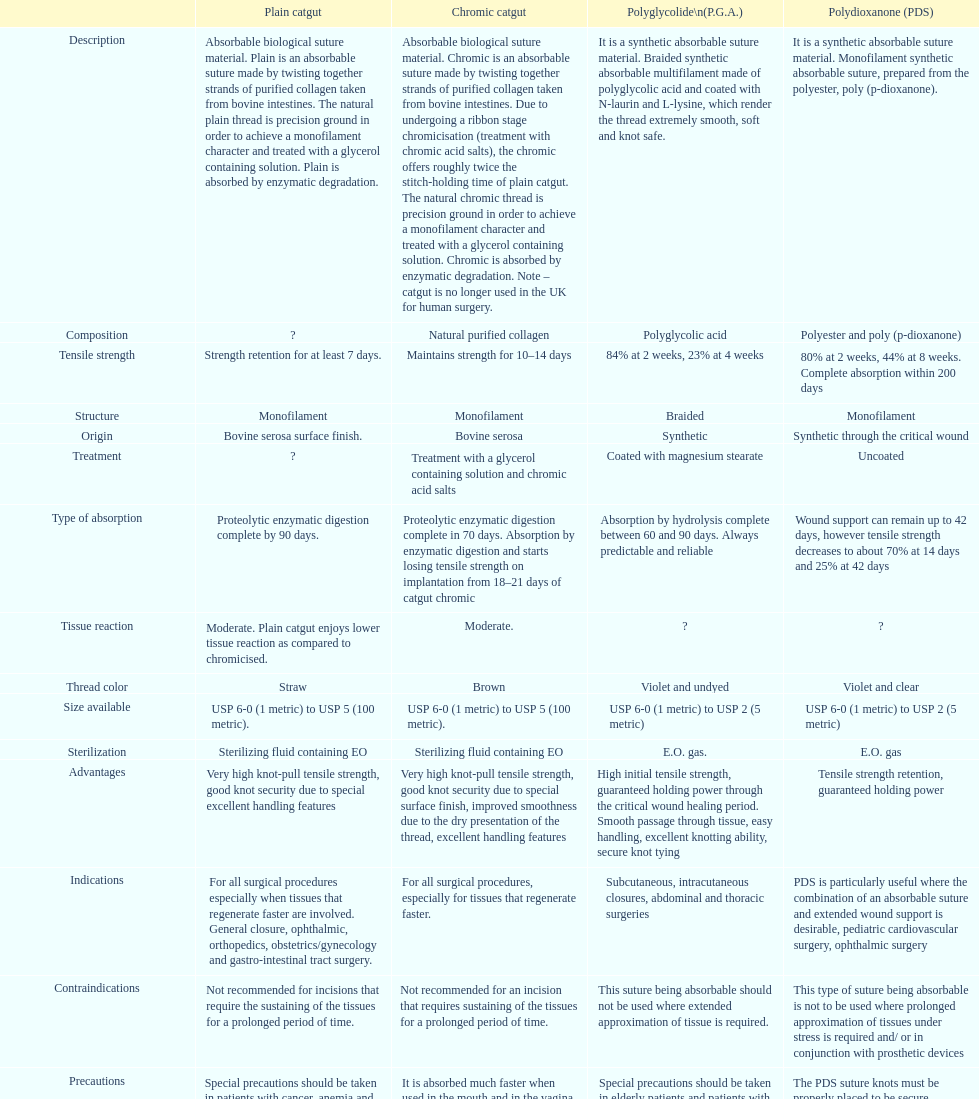Unadorned catgut and chromic catgut both exhibit what form of structure? Monofilament. 